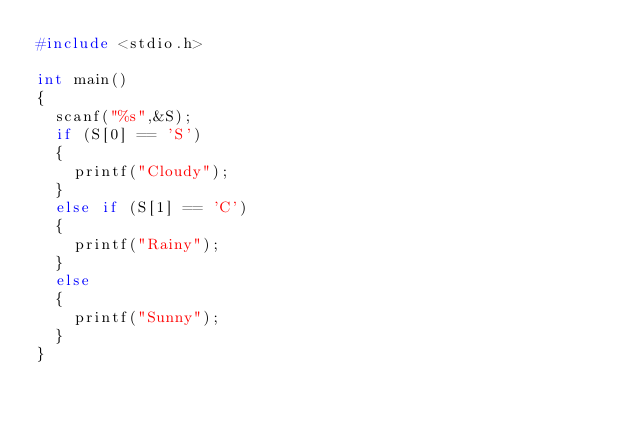Convert code to text. <code><loc_0><loc_0><loc_500><loc_500><_C_>#include <stdio.h>

int main()
{
  scanf("%s",&S);
  if (S[0] == 'S')
  {
    printf("Cloudy");
  }
  else if (S[1] == 'C')
  {
    printf("Rainy");
  }
  else
  {
    printf("Sunny");
  }
}</code> 